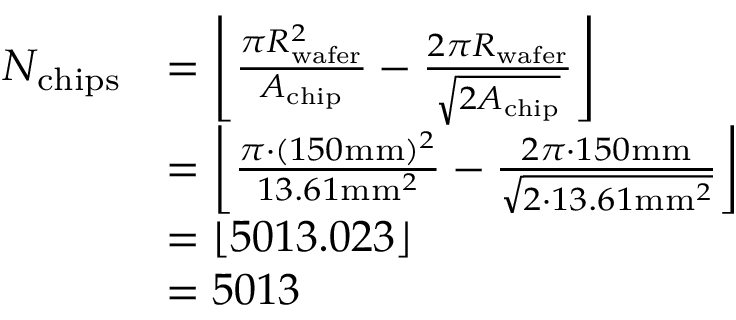Convert formula to latex. <formula><loc_0><loc_0><loc_500><loc_500>\begin{array} { r l } { N _ { c h i p s } } & { = \left \lfloor \frac { \pi R _ { w a f e r } ^ { 2 } } { A _ { c h i p } } - \frac { 2 \pi R _ { w a f e r } } { \sqrt { 2 A _ { c h i p } } } \right \rfloor } \\ & { = \left \lfloor \frac { \pi \cdot ( 1 5 0 m m ) ^ { 2 } } { 1 3 . 6 1 m m ^ { 2 } } - \frac { 2 \pi \cdot 1 5 0 m m } { \sqrt { 2 \cdot 1 3 . 6 1 m m ^ { 2 } } } \right \rfloor } \\ & { = \left \lfloor 5 0 1 3 . 0 2 3 \right \rfloor } \\ & { = 5 0 1 3 } \end{array}</formula> 